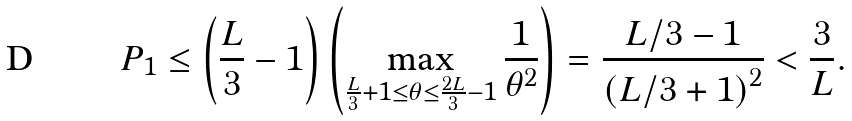<formula> <loc_0><loc_0><loc_500><loc_500>P _ { 1 } \leq \left ( \frac { L } { 3 } - 1 \right ) \left ( \max _ { \frac { L } { 3 } + 1 \leq \theta \leq \frac { 2 L } { 3 } - 1 } \frac { 1 } { \theta ^ { 2 } } \right ) = \frac { L / 3 - 1 } { \left ( L / 3 + 1 \right ) ^ { 2 } } < \frac { 3 } { L } .</formula> 